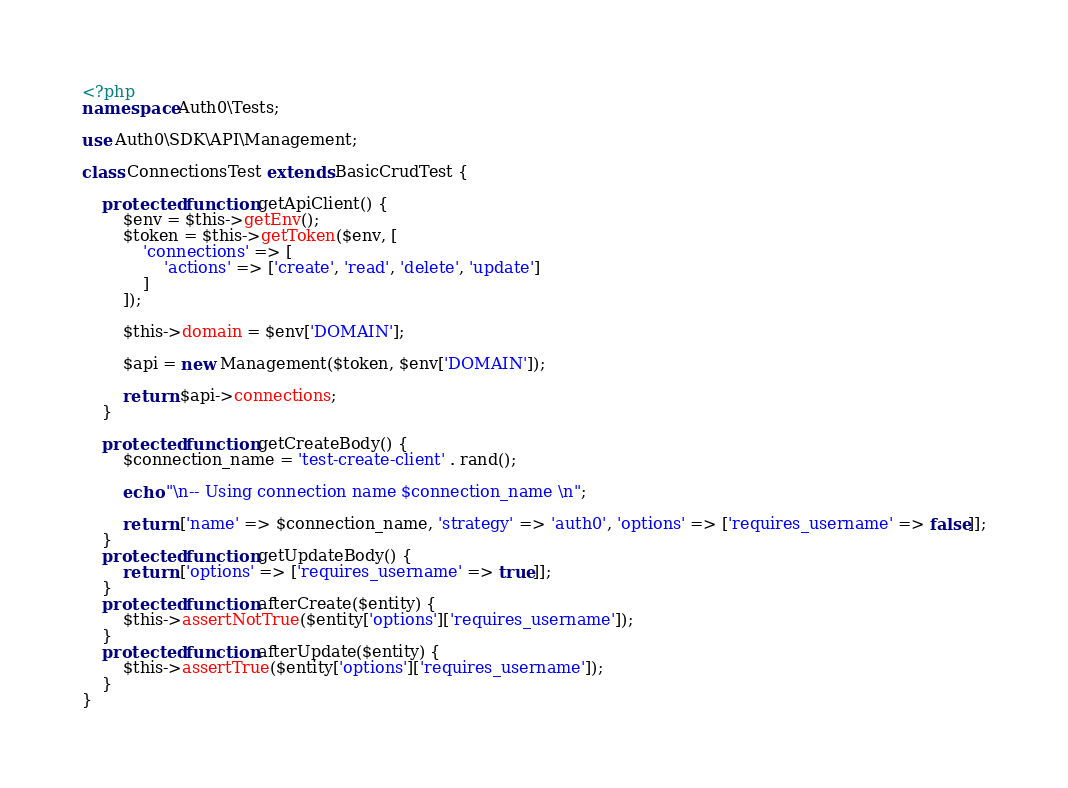<code> <loc_0><loc_0><loc_500><loc_500><_PHP_><?php
namespace Auth0\Tests;

use Auth0\SDK\API\Management;

class ConnectionsTest extends BasicCrudTest {

    protected function getApiClient() {
        $env = $this->getEnv();
        $token = $this->getToken($env, [
            'connections' => [
                'actions' => ['create', 'read', 'delete', 'update']
            ]
        ]);

        $this->domain = $env['DOMAIN'];

        $api = new Management($token, $env['DOMAIN']);

        return $api->connections;
    }

    protected function getCreateBody() {
        $connection_name = 'test-create-client' . rand();

        echo "\n-- Using connection name $connection_name \n";

        return ['name' => $connection_name, 'strategy' => 'auth0', 'options' => ['requires_username' => false]];
    }
    protected function getUpdateBody() {
        return ['options' => ['requires_username' => true]];
    }
    protected function afterCreate($entity) {
        $this->assertNotTrue($entity['options']['requires_username']);
    }
    protected function afterUpdate($entity) {
        $this->assertTrue($entity['options']['requires_username']);
    }
}</code> 